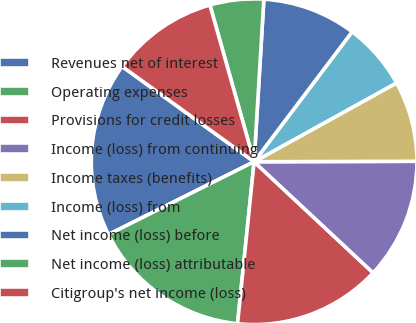Convert chart to OTSL. <chart><loc_0><loc_0><loc_500><loc_500><pie_chart><fcel>Revenues net of interest<fcel>Operating expenses<fcel>Provisions for credit losses<fcel>Income (loss) from continuing<fcel>Income taxes (benefits)<fcel>Income (loss) from<fcel>Net income (loss) before<fcel>Net income (loss) attributable<fcel>Citigroup's net income (loss)<nl><fcel>17.33%<fcel>16.0%<fcel>14.67%<fcel>12.0%<fcel>8.0%<fcel>6.67%<fcel>9.33%<fcel>5.33%<fcel>10.67%<nl></chart> 